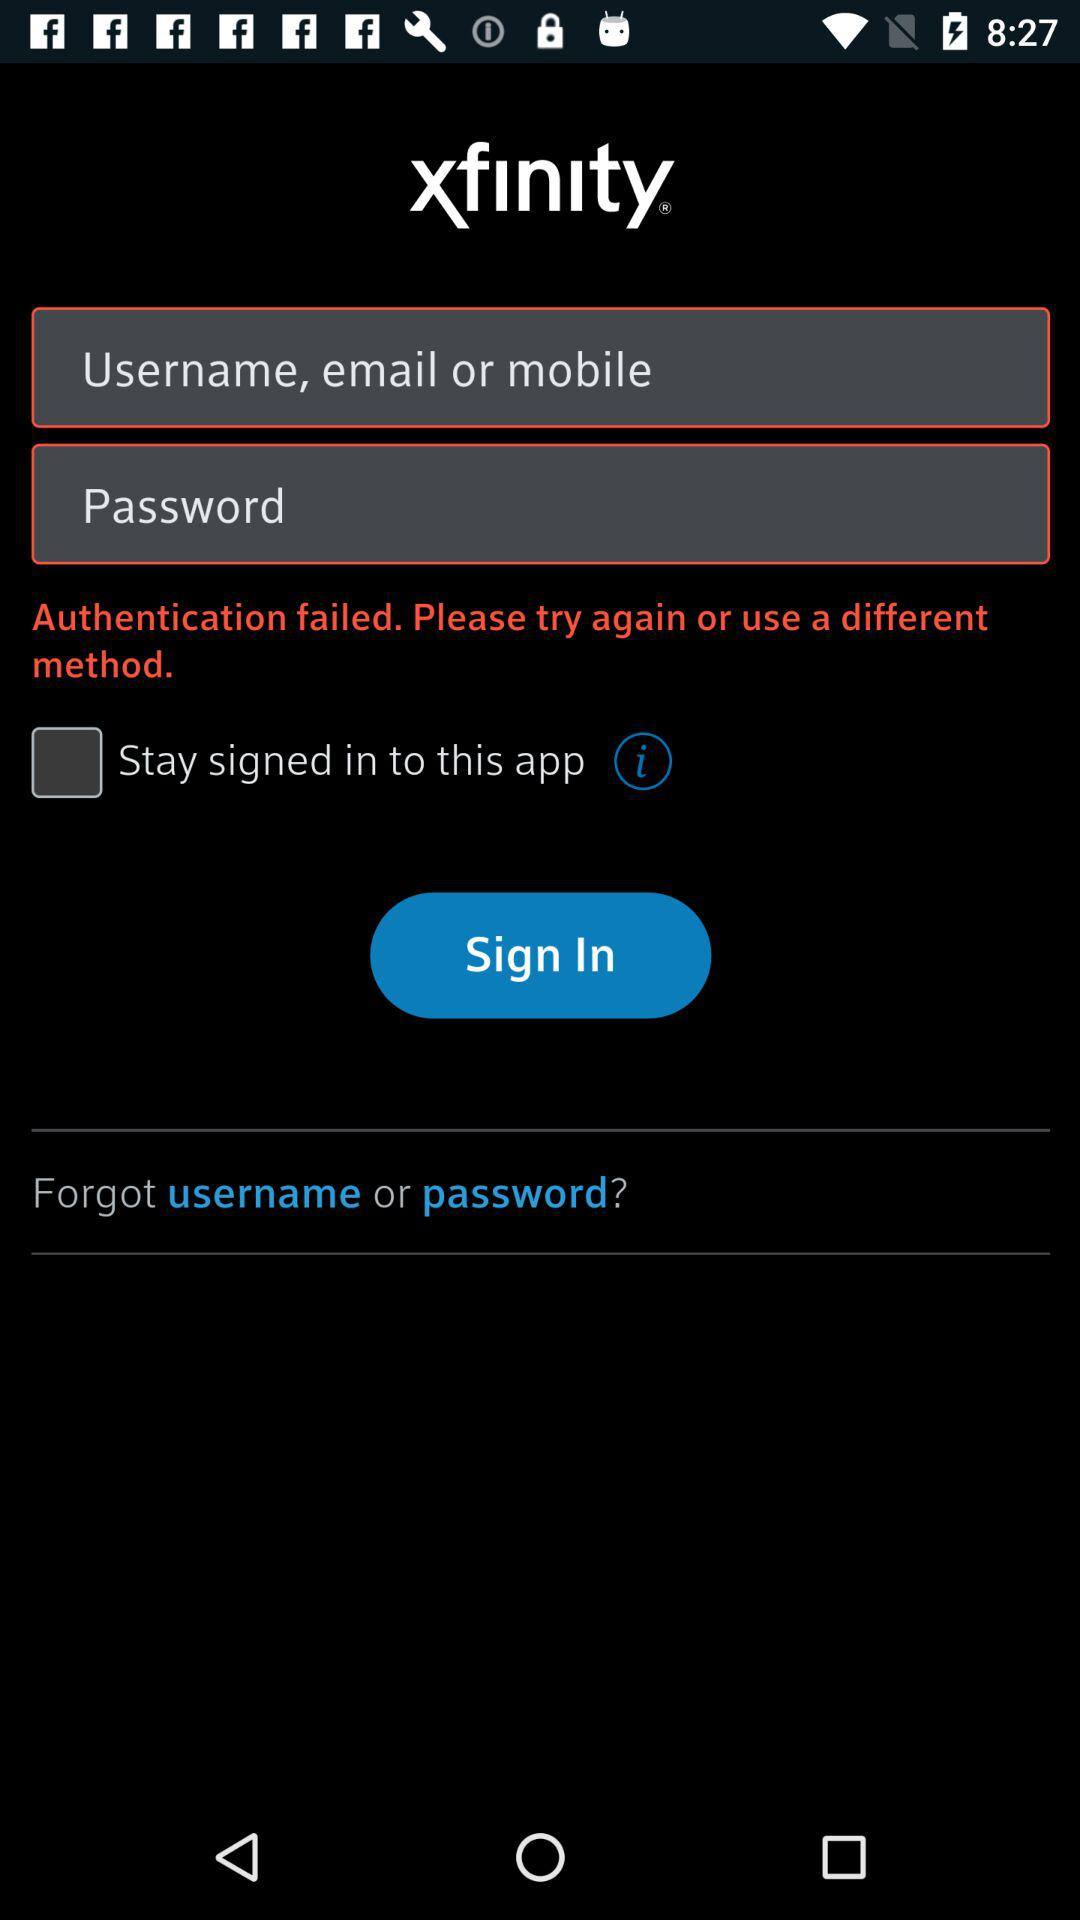What is the application name? The application name is "xfinity". 